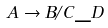Convert formula to latex. <formula><loc_0><loc_0><loc_500><loc_500>A \rightarrow B / C \_ D</formula> 